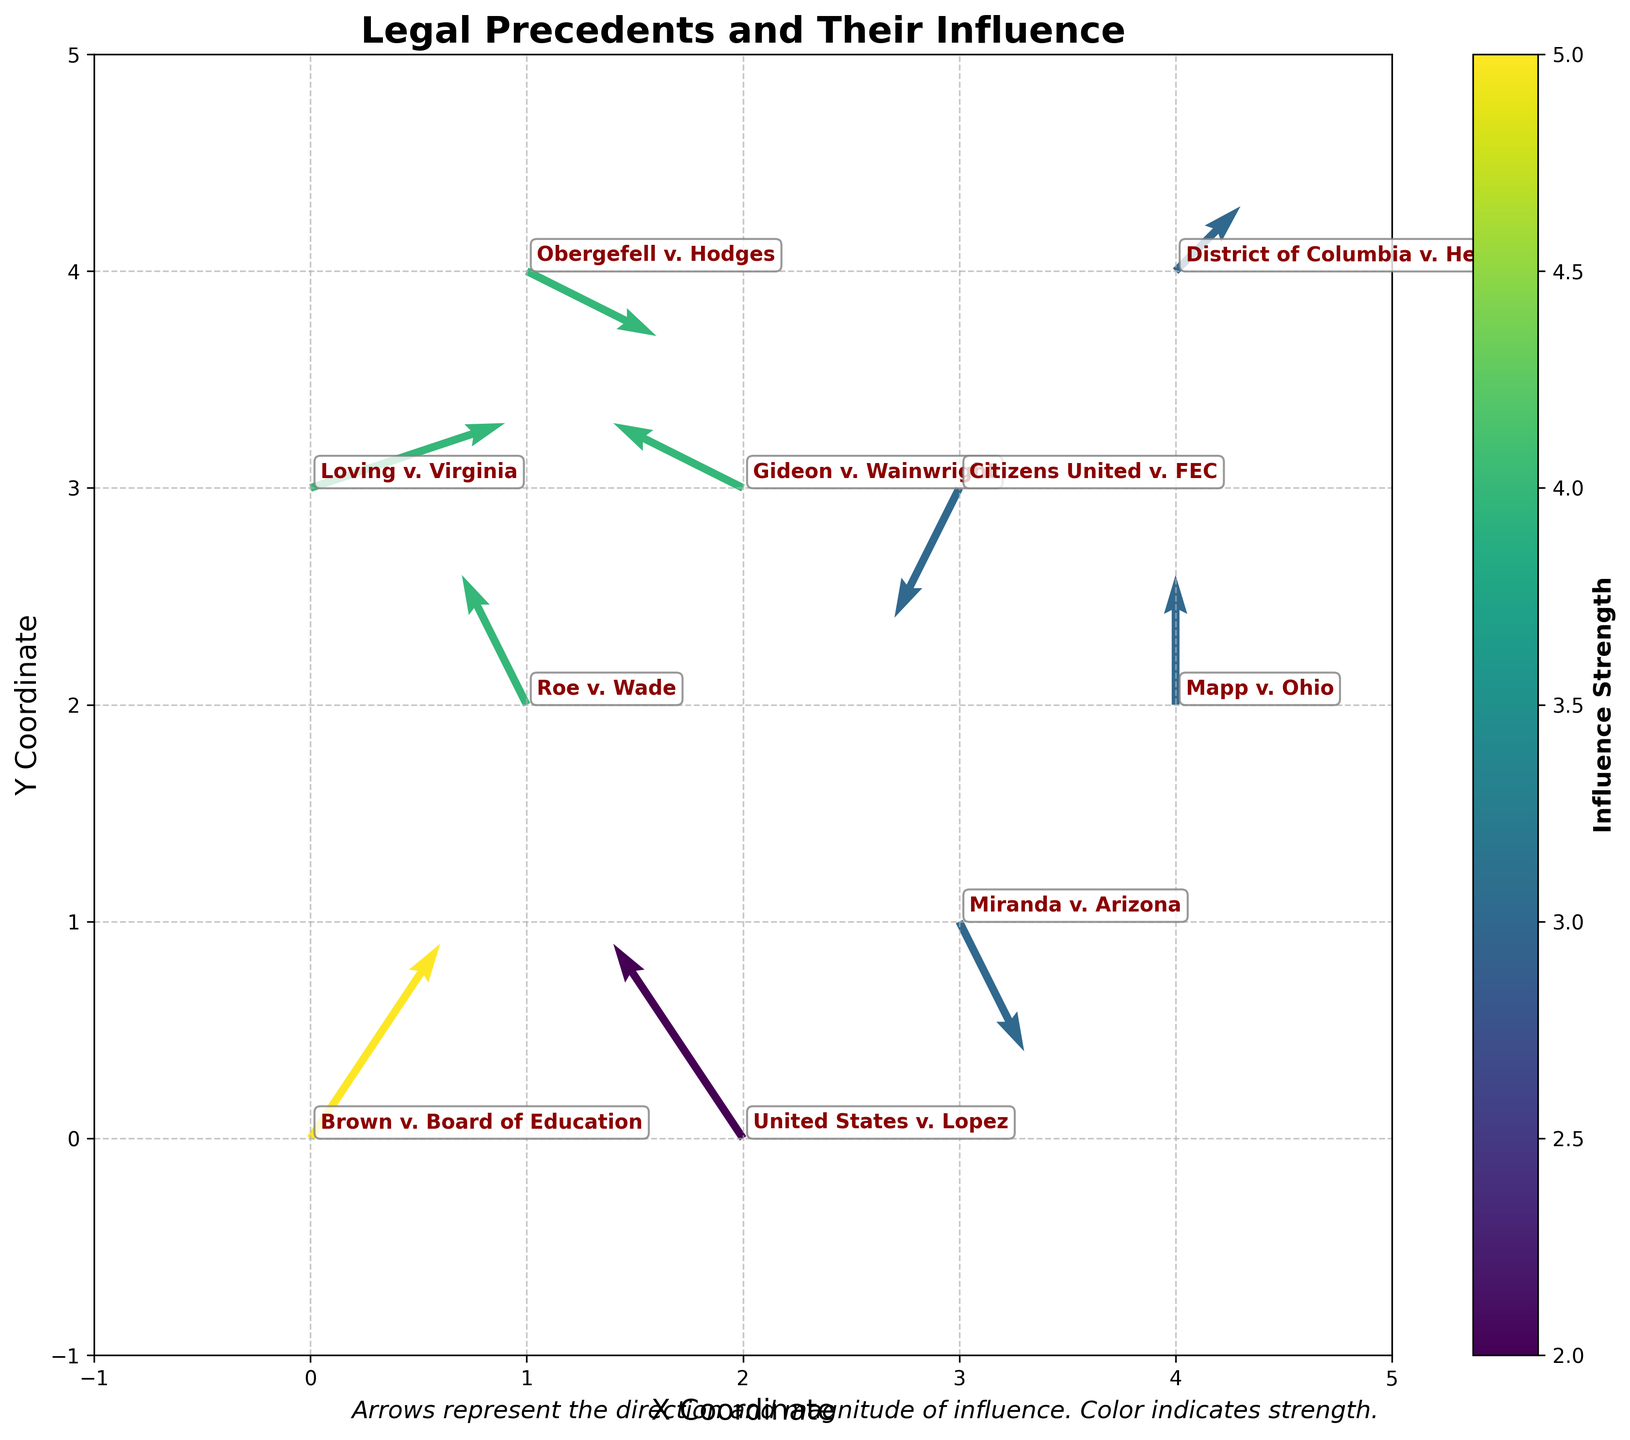What is the title of the plot? The title is usually found at the top of the figure and is meant to give a quick insight into what the plot represents. Reading the title directly from the plot, we see it as ‘Legal Precedents and Their Influence’.
Answer: Legal Precedents and Their Influence How many court cases are represented in the plot? Each arrow (vector) in the quiver plot represents a court case. To count the number of court cases, we count the number of arrows shown. There are 10 arrows, thus there are 10 court cases represented.
Answer: 10 Which case has the highest influence strength? The color bar indicates that lighter colors show higher influence strength. Checking the annotations, 'Brown v. Board of Education' is highlighted prominently. Its influence strength is the highest, valued at 5.
Answer: Brown v. Board of Education Where is 'Roe v. Wade' located in the plot? The case 'Roe v. Wade' is annotated and can be found by locating its name on the plot. It is positioned at (1, 2).
Answer: (1, 2) What is the direction of influence for 'Miranda v. Arizona'? Arrows represent the direction of influence. 'Miranda v. Arizona' has an arrow pointing right downward (1, -2). Thus, the direction is mostly to the right and downward.
Answer: Right downward Which case has the longest vector (arrow) in the plot? The length of the vector can be calculated using the Pythagorean theorem, where length (L) = √(u² + v²). 'Brown v. Board of Education' has the longest vector with L = √(2² + 3²) = √13 which is the highest calculated value among all the vectors.
Answer: Brown v. Board of Education Compare the influence directions of 'Loving v. Virginia' and 'Obergefell v. Hodges'. Are they the same? 'Loving v. Virginia' has a vector (3, 1), and 'Obergefell v. Hodges' has a vector (2, -1). The directions are different, as one points rightward and slightly upward, and the other points rightward and downward.
Answer: No By observing overall arrow directions, which general direction shows a stronger influence on subsequent decisions? General observations show that most arrows point rightwards. This could indicate most influential decisions somewhat affect subsequent decisions towards a forward momentum. Verification through exact analysis might be required for accuracy.
Answer: Rightwards What is the common influence strength value seen in most cases? By examining the color gradient and comparing the arrows, we find that the most frequent color indicates an influence strength of 3 or 4, as seen in several cases like 'Roe v. Wade', 'Miranda v. Arizona', and 'Loving v. Virginia'.
Answer: 3 or 4 